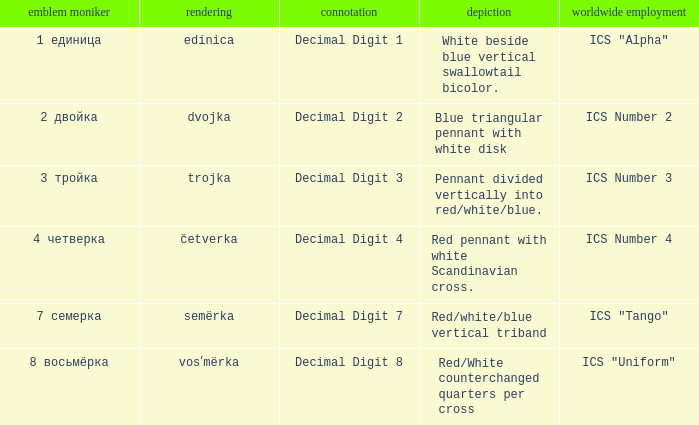Could you parse the entire table as a dict? {'header': ['emblem moniker', 'rendering', 'connotation', 'depiction', 'worldwide employment'], 'rows': [['1 единица', 'edinica', 'Decimal Digit 1', 'White beside blue vertical swallowtail bicolor.', 'ICS "Alpha"'], ['2 двойка', 'dvojka', 'Decimal Digit 2', 'Blue triangular pennant with white disk', 'ICS Number 2'], ['3 тройка', 'trojka', 'Decimal Digit 3', 'Pennant divided vertically into red/white/blue.', 'ICS Number 3'], ['4 четверка', 'četverka', 'Decimal Digit 4', 'Red pennant with white Scandinavian cross.', 'ICS Number 4'], ['7 семерка', 'semërka', 'Decimal Digit 7', 'Red/white/blue vertical triband', 'ICS "Tango"'], ['8 восьмёрка', 'vosʹmërka', 'Decimal Digit 8', 'Red/White counterchanged quarters per cross', 'ICS "Uniform"']]} What are the meanings of the flag whose name transliterates to dvojka? Decimal Digit 2. 